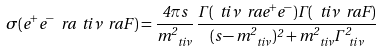Convert formula to latex. <formula><loc_0><loc_0><loc_500><loc_500>\sigma ( e ^ { + } e ^ { - } \ r a \ t i { \nu } \ r a F ) = \frac { 4 \pi s } { m ^ { 2 } _ { \ t i { \nu } } } \, \frac { \Gamma ( \ t i { \nu } \ r a e ^ { + } e ^ { - } ) \Gamma ( \ t i { \nu } \ r a F ) } { ( s - m ^ { 2 } _ { \ t i { \nu } } ) ^ { 2 } + m _ { \ t i { \nu } } ^ { 2 } \Gamma ^ { 2 } _ { \ t i { \nu } } }</formula> 